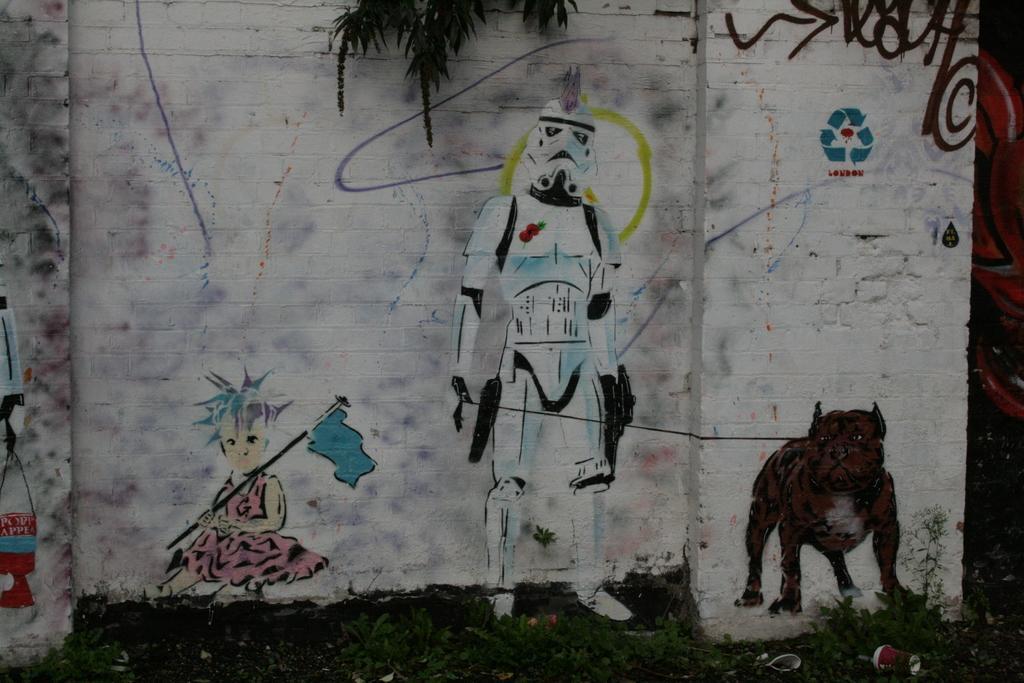Please provide a concise description of this image. This picture shows painting on the wall and we see a tree and grass on the ground. 